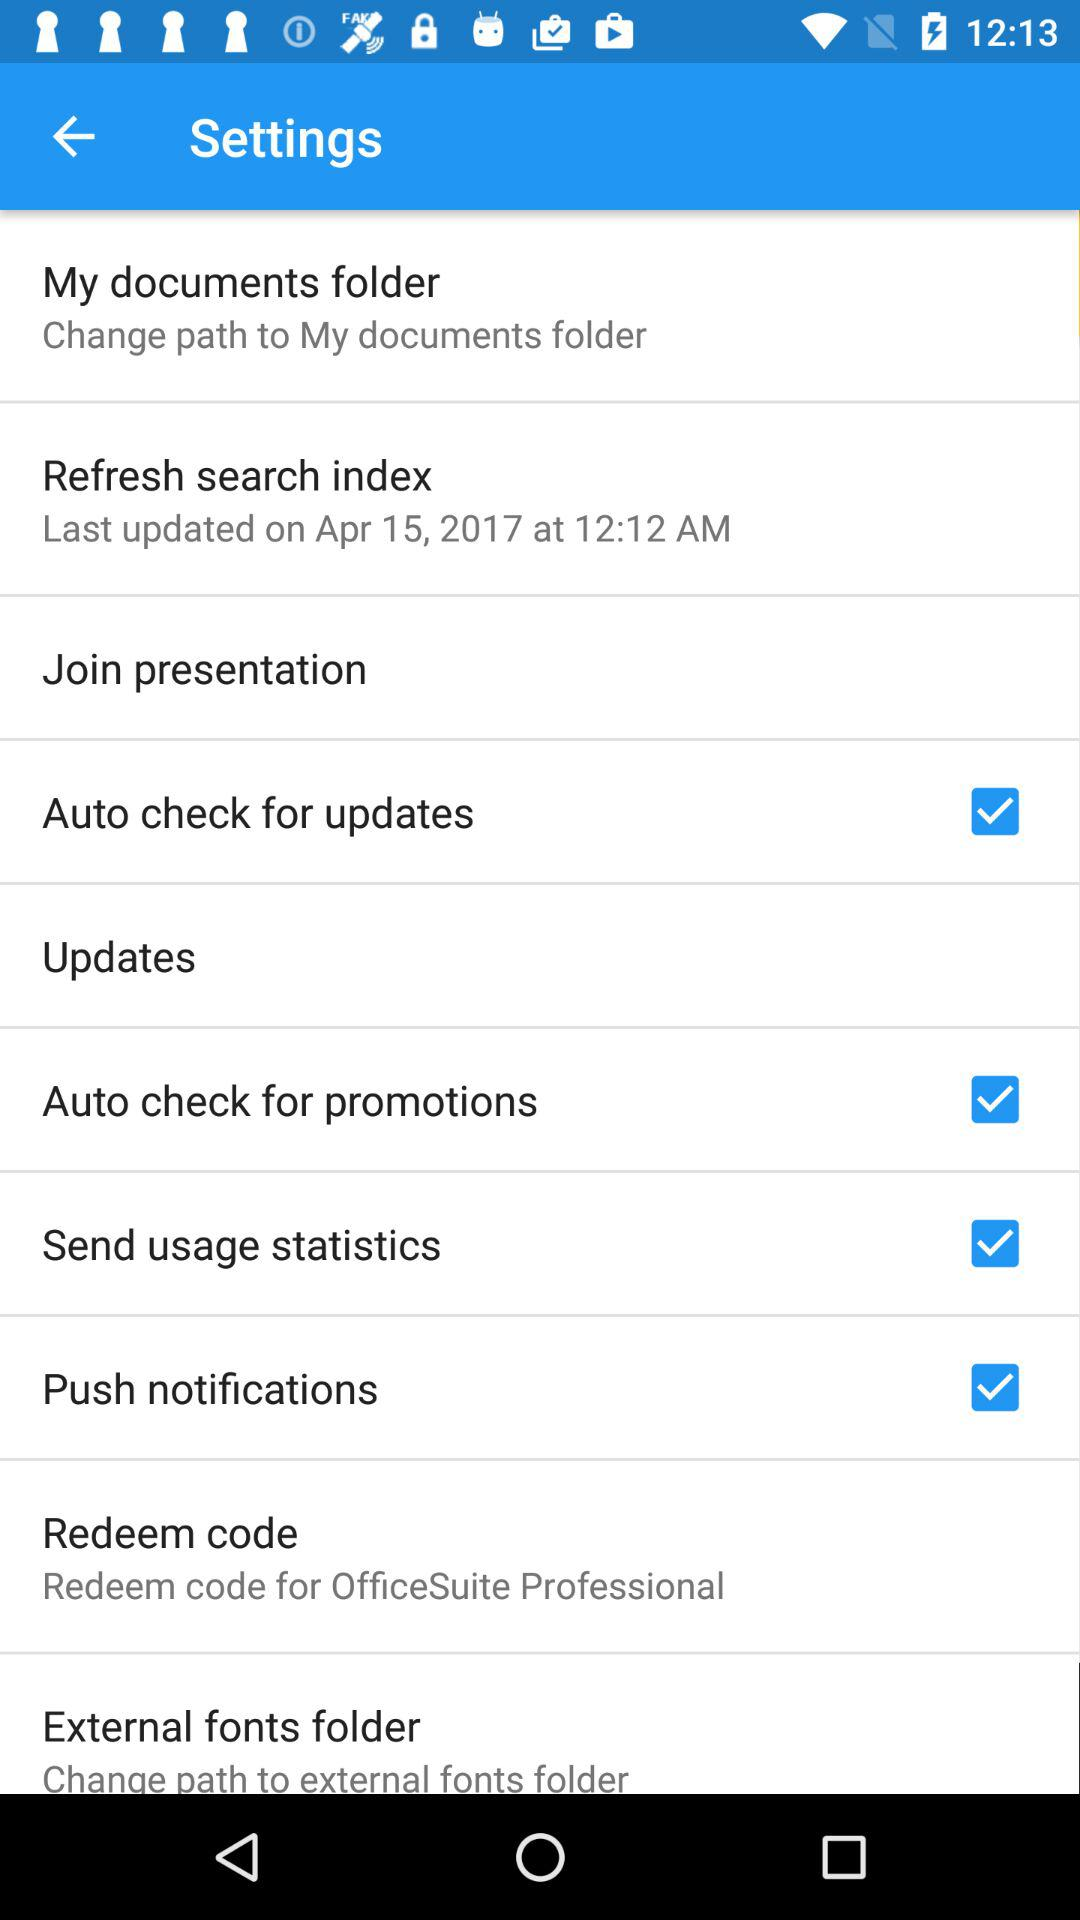Which settings are selected? The selected settings are "Auto check for updates", "Auto check for promotions", "Send usage statistics" and "Push notifications". 